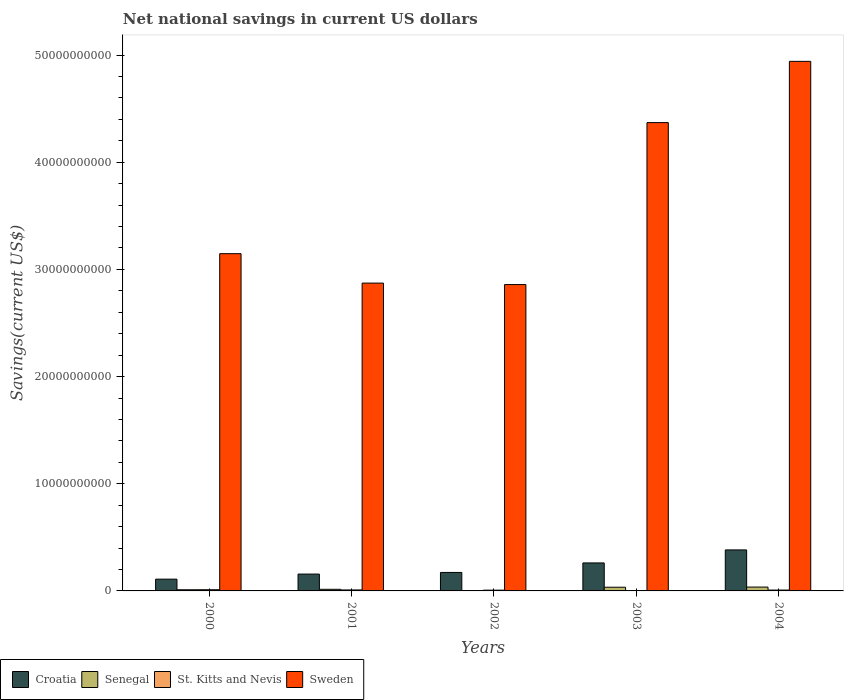How many different coloured bars are there?
Give a very brief answer. 4. How many bars are there on the 1st tick from the left?
Your answer should be very brief. 4. How many bars are there on the 1st tick from the right?
Offer a very short reply. 4. What is the label of the 1st group of bars from the left?
Offer a terse response. 2000. What is the net national savings in Senegal in 2004?
Your answer should be compact. 3.59e+08. Across all years, what is the maximum net national savings in Croatia?
Keep it short and to the point. 3.83e+09. Across all years, what is the minimum net national savings in Sweden?
Give a very brief answer. 2.86e+1. In which year was the net national savings in St. Kitts and Nevis maximum?
Your answer should be compact. 2000. What is the total net national savings in Sweden in the graph?
Ensure brevity in your answer.  1.82e+11. What is the difference between the net national savings in St. Kitts and Nevis in 2003 and that in 2004?
Provide a short and direct response. -4.76e+07. What is the difference between the net national savings in St. Kitts and Nevis in 2000 and the net national savings in Sweden in 2002?
Your answer should be compact. -2.85e+1. What is the average net national savings in Senegal per year?
Your response must be concise. 1.96e+08. In the year 2004, what is the difference between the net national savings in Sweden and net national savings in Senegal?
Your response must be concise. 4.91e+1. In how many years, is the net national savings in Croatia greater than 36000000000 US$?
Your answer should be compact. 0. What is the ratio of the net national savings in St. Kitts and Nevis in 2000 to that in 2001?
Give a very brief answer. 1.23. What is the difference between the highest and the second highest net national savings in Croatia?
Keep it short and to the point. 1.21e+09. What is the difference between the highest and the lowest net national savings in Senegal?
Give a very brief answer. 3.42e+08. What does the 1st bar from the left in 2001 represents?
Offer a terse response. Croatia. What does the 3rd bar from the right in 2001 represents?
Give a very brief answer. Senegal. How many bars are there?
Your answer should be very brief. 20. How many years are there in the graph?
Your response must be concise. 5. What is the difference between two consecutive major ticks on the Y-axis?
Your answer should be very brief. 1.00e+1. Are the values on the major ticks of Y-axis written in scientific E-notation?
Provide a succinct answer. No. Where does the legend appear in the graph?
Make the answer very short. Bottom left. How are the legend labels stacked?
Provide a succinct answer. Horizontal. What is the title of the graph?
Keep it short and to the point. Net national savings in current US dollars. Does "Mali" appear as one of the legend labels in the graph?
Provide a succinct answer. No. What is the label or title of the Y-axis?
Provide a succinct answer. Savings(current US$). What is the Savings(current US$) in Croatia in 2000?
Your response must be concise. 1.10e+09. What is the Savings(current US$) in Senegal in 2000?
Your answer should be very brief. 1.09e+08. What is the Savings(current US$) in St. Kitts and Nevis in 2000?
Provide a short and direct response. 1.12e+08. What is the Savings(current US$) in Sweden in 2000?
Give a very brief answer. 3.15e+1. What is the Savings(current US$) of Croatia in 2001?
Keep it short and to the point. 1.57e+09. What is the Savings(current US$) of Senegal in 2001?
Your answer should be compact. 1.51e+08. What is the Savings(current US$) of St. Kitts and Nevis in 2001?
Provide a short and direct response. 9.14e+07. What is the Savings(current US$) in Sweden in 2001?
Your answer should be compact. 2.87e+1. What is the Savings(current US$) in Croatia in 2002?
Offer a terse response. 1.72e+09. What is the Savings(current US$) in Senegal in 2002?
Keep it short and to the point. 1.67e+07. What is the Savings(current US$) in St. Kitts and Nevis in 2002?
Give a very brief answer. 7.03e+07. What is the Savings(current US$) in Sweden in 2002?
Your answer should be compact. 2.86e+1. What is the Savings(current US$) of Croatia in 2003?
Your answer should be compact. 2.61e+09. What is the Savings(current US$) in Senegal in 2003?
Offer a very short reply. 3.44e+08. What is the Savings(current US$) of St. Kitts and Nevis in 2003?
Your response must be concise. 3.22e+07. What is the Savings(current US$) of Sweden in 2003?
Give a very brief answer. 4.37e+1. What is the Savings(current US$) in Croatia in 2004?
Make the answer very short. 3.83e+09. What is the Savings(current US$) in Senegal in 2004?
Your answer should be very brief. 3.59e+08. What is the Savings(current US$) of St. Kitts and Nevis in 2004?
Provide a short and direct response. 7.98e+07. What is the Savings(current US$) in Sweden in 2004?
Keep it short and to the point. 4.94e+1. Across all years, what is the maximum Savings(current US$) of Croatia?
Provide a succinct answer. 3.83e+09. Across all years, what is the maximum Savings(current US$) in Senegal?
Provide a succinct answer. 3.59e+08. Across all years, what is the maximum Savings(current US$) of St. Kitts and Nevis?
Your response must be concise. 1.12e+08. Across all years, what is the maximum Savings(current US$) in Sweden?
Ensure brevity in your answer.  4.94e+1. Across all years, what is the minimum Savings(current US$) of Croatia?
Keep it short and to the point. 1.10e+09. Across all years, what is the minimum Savings(current US$) of Senegal?
Offer a terse response. 1.67e+07. Across all years, what is the minimum Savings(current US$) of St. Kitts and Nevis?
Make the answer very short. 3.22e+07. Across all years, what is the minimum Savings(current US$) of Sweden?
Ensure brevity in your answer.  2.86e+1. What is the total Savings(current US$) in Croatia in the graph?
Your answer should be very brief. 1.08e+1. What is the total Savings(current US$) in Senegal in the graph?
Your answer should be very brief. 9.80e+08. What is the total Savings(current US$) of St. Kitts and Nevis in the graph?
Make the answer very short. 3.86e+08. What is the total Savings(current US$) of Sweden in the graph?
Ensure brevity in your answer.  1.82e+11. What is the difference between the Savings(current US$) of Croatia in 2000 and that in 2001?
Your answer should be very brief. -4.74e+08. What is the difference between the Savings(current US$) in Senegal in 2000 and that in 2001?
Offer a terse response. -4.20e+07. What is the difference between the Savings(current US$) of St. Kitts and Nevis in 2000 and that in 2001?
Keep it short and to the point. 2.07e+07. What is the difference between the Savings(current US$) of Sweden in 2000 and that in 2001?
Your answer should be compact. 2.75e+09. What is the difference between the Savings(current US$) of Croatia in 2000 and that in 2002?
Make the answer very short. -6.25e+08. What is the difference between the Savings(current US$) in Senegal in 2000 and that in 2002?
Offer a terse response. 9.25e+07. What is the difference between the Savings(current US$) of St. Kitts and Nevis in 2000 and that in 2002?
Offer a terse response. 4.18e+07. What is the difference between the Savings(current US$) of Sweden in 2000 and that in 2002?
Your response must be concise. 2.88e+09. What is the difference between the Savings(current US$) of Croatia in 2000 and that in 2003?
Offer a terse response. -1.51e+09. What is the difference between the Savings(current US$) in Senegal in 2000 and that in 2003?
Your answer should be very brief. -2.35e+08. What is the difference between the Savings(current US$) of St. Kitts and Nevis in 2000 and that in 2003?
Provide a succinct answer. 7.99e+07. What is the difference between the Savings(current US$) of Sweden in 2000 and that in 2003?
Offer a terse response. -1.22e+1. What is the difference between the Savings(current US$) of Croatia in 2000 and that in 2004?
Give a very brief answer. -2.73e+09. What is the difference between the Savings(current US$) in Senegal in 2000 and that in 2004?
Give a very brief answer. -2.50e+08. What is the difference between the Savings(current US$) in St. Kitts and Nevis in 2000 and that in 2004?
Give a very brief answer. 3.23e+07. What is the difference between the Savings(current US$) of Sweden in 2000 and that in 2004?
Your answer should be very brief. -1.79e+1. What is the difference between the Savings(current US$) of Croatia in 2001 and that in 2002?
Ensure brevity in your answer.  -1.51e+08. What is the difference between the Savings(current US$) of Senegal in 2001 and that in 2002?
Provide a succinct answer. 1.35e+08. What is the difference between the Savings(current US$) in St. Kitts and Nevis in 2001 and that in 2002?
Your answer should be compact. 2.11e+07. What is the difference between the Savings(current US$) in Sweden in 2001 and that in 2002?
Keep it short and to the point. 1.37e+08. What is the difference between the Savings(current US$) in Croatia in 2001 and that in 2003?
Your response must be concise. -1.04e+09. What is the difference between the Savings(current US$) of Senegal in 2001 and that in 2003?
Make the answer very short. -1.93e+08. What is the difference between the Savings(current US$) in St. Kitts and Nevis in 2001 and that in 2003?
Make the answer very short. 5.92e+07. What is the difference between the Savings(current US$) in Sweden in 2001 and that in 2003?
Your answer should be compact. -1.50e+1. What is the difference between the Savings(current US$) of Croatia in 2001 and that in 2004?
Ensure brevity in your answer.  -2.25e+09. What is the difference between the Savings(current US$) in Senegal in 2001 and that in 2004?
Ensure brevity in your answer.  -2.08e+08. What is the difference between the Savings(current US$) in St. Kitts and Nevis in 2001 and that in 2004?
Give a very brief answer. 1.16e+07. What is the difference between the Savings(current US$) in Sweden in 2001 and that in 2004?
Provide a succinct answer. -2.07e+1. What is the difference between the Savings(current US$) of Croatia in 2002 and that in 2003?
Ensure brevity in your answer.  -8.88e+08. What is the difference between the Savings(current US$) of Senegal in 2002 and that in 2003?
Make the answer very short. -3.28e+08. What is the difference between the Savings(current US$) in St. Kitts and Nevis in 2002 and that in 2003?
Provide a succinct answer. 3.81e+07. What is the difference between the Savings(current US$) in Sweden in 2002 and that in 2003?
Your response must be concise. -1.51e+1. What is the difference between the Savings(current US$) of Croatia in 2002 and that in 2004?
Provide a short and direct response. -2.10e+09. What is the difference between the Savings(current US$) in Senegal in 2002 and that in 2004?
Make the answer very short. -3.42e+08. What is the difference between the Savings(current US$) of St. Kitts and Nevis in 2002 and that in 2004?
Provide a short and direct response. -9.49e+06. What is the difference between the Savings(current US$) of Sweden in 2002 and that in 2004?
Provide a succinct answer. -2.08e+1. What is the difference between the Savings(current US$) of Croatia in 2003 and that in 2004?
Your response must be concise. -1.21e+09. What is the difference between the Savings(current US$) of Senegal in 2003 and that in 2004?
Ensure brevity in your answer.  -1.45e+07. What is the difference between the Savings(current US$) of St. Kitts and Nevis in 2003 and that in 2004?
Offer a very short reply. -4.76e+07. What is the difference between the Savings(current US$) in Sweden in 2003 and that in 2004?
Ensure brevity in your answer.  -5.72e+09. What is the difference between the Savings(current US$) of Croatia in 2000 and the Savings(current US$) of Senegal in 2001?
Provide a short and direct response. 9.48e+08. What is the difference between the Savings(current US$) of Croatia in 2000 and the Savings(current US$) of St. Kitts and Nevis in 2001?
Ensure brevity in your answer.  1.01e+09. What is the difference between the Savings(current US$) in Croatia in 2000 and the Savings(current US$) in Sweden in 2001?
Ensure brevity in your answer.  -2.76e+1. What is the difference between the Savings(current US$) of Senegal in 2000 and the Savings(current US$) of St. Kitts and Nevis in 2001?
Offer a very short reply. 1.78e+07. What is the difference between the Savings(current US$) in Senegal in 2000 and the Savings(current US$) in Sweden in 2001?
Keep it short and to the point. -2.86e+1. What is the difference between the Savings(current US$) of St. Kitts and Nevis in 2000 and the Savings(current US$) of Sweden in 2001?
Keep it short and to the point. -2.86e+1. What is the difference between the Savings(current US$) of Croatia in 2000 and the Savings(current US$) of Senegal in 2002?
Your answer should be compact. 1.08e+09. What is the difference between the Savings(current US$) in Croatia in 2000 and the Savings(current US$) in St. Kitts and Nevis in 2002?
Keep it short and to the point. 1.03e+09. What is the difference between the Savings(current US$) in Croatia in 2000 and the Savings(current US$) in Sweden in 2002?
Offer a terse response. -2.75e+1. What is the difference between the Savings(current US$) of Senegal in 2000 and the Savings(current US$) of St. Kitts and Nevis in 2002?
Make the answer very short. 3.89e+07. What is the difference between the Savings(current US$) in Senegal in 2000 and the Savings(current US$) in Sweden in 2002?
Your answer should be compact. -2.85e+1. What is the difference between the Savings(current US$) of St. Kitts and Nevis in 2000 and the Savings(current US$) of Sweden in 2002?
Provide a succinct answer. -2.85e+1. What is the difference between the Savings(current US$) in Croatia in 2000 and the Savings(current US$) in Senegal in 2003?
Your response must be concise. 7.55e+08. What is the difference between the Savings(current US$) in Croatia in 2000 and the Savings(current US$) in St. Kitts and Nevis in 2003?
Keep it short and to the point. 1.07e+09. What is the difference between the Savings(current US$) in Croatia in 2000 and the Savings(current US$) in Sweden in 2003?
Provide a succinct answer. -4.26e+1. What is the difference between the Savings(current US$) in Senegal in 2000 and the Savings(current US$) in St. Kitts and Nevis in 2003?
Offer a terse response. 7.70e+07. What is the difference between the Savings(current US$) in Senegal in 2000 and the Savings(current US$) in Sweden in 2003?
Offer a very short reply. -4.36e+1. What is the difference between the Savings(current US$) in St. Kitts and Nevis in 2000 and the Savings(current US$) in Sweden in 2003?
Offer a very short reply. -4.36e+1. What is the difference between the Savings(current US$) in Croatia in 2000 and the Savings(current US$) in Senegal in 2004?
Make the answer very short. 7.40e+08. What is the difference between the Savings(current US$) in Croatia in 2000 and the Savings(current US$) in St. Kitts and Nevis in 2004?
Offer a terse response. 1.02e+09. What is the difference between the Savings(current US$) of Croatia in 2000 and the Savings(current US$) of Sweden in 2004?
Offer a very short reply. -4.83e+1. What is the difference between the Savings(current US$) in Senegal in 2000 and the Savings(current US$) in St. Kitts and Nevis in 2004?
Your answer should be very brief. 2.94e+07. What is the difference between the Savings(current US$) of Senegal in 2000 and the Savings(current US$) of Sweden in 2004?
Provide a succinct answer. -4.93e+1. What is the difference between the Savings(current US$) of St. Kitts and Nevis in 2000 and the Savings(current US$) of Sweden in 2004?
Offer a terse response. -4.93e+1. What is the difference between the Savings(current US$) of Croatia in 2001 and the Savings(current US$) of Senegal in 2002?
Offer a very short reply. 1.56e+09. What is the difference between the Savings(current US$) in Croatia in 2001 and the Savings(current US$) in St. Kitts and Nevis in 2002?
Make the answer very short. 1.50e+09. What is the difference between the Savings(current US$) in Croatia in 2001 and the Savings(current US$) in Sweden in 2002?
Offer a terse response. -2.70e+1. What is the difference between the Savings(current US$) of Senegal in 2001 and the Savings(current US$) of St. Kitts and Nevis in 2002?
Give a very brief answer. 8.09e+07. What is the difference between the Savings(current US$) of Senegal in 2001 and the Savings(current US$) of Sweden in 2002?
Offer a very short reply. -2.84e+1. What is the difference between the Savings(current US$) in St. Kitts and Nevis in 2001 and the Savings(current US$) in Sweden in 2002?
Give a very brief answer. -2.85e+1. What is the difference between the Savings(current US$) of Croatia in 2001 and the Savings(current US$) of Senegal in 2003?
Offer a terse response. 1.23e+09. What is the difference between the Savings(current US$) in Croatia in 2001 and the Savings(current US$) in St. Kitts and Nevis in 2003?
Make the answer very short. 1.54e+09. What is the difference between the Savings(current US$) of Croatia in 2001 and the Savings(current US$) of Sweden in 2003?
Make the answer very short. -4.21e+1. What is the difference between the Savings(current US$) of Senegal in 2001 and the Savings(current US$) of St. Kitts and Nevis in 2003?
Your answer should be compact. 1.19e+08. What is the difference between the Savings(current US$) in Senegal in 2001 and the Savings(current US$) in Sweden in 2003?
Offer a terse response. -4.35e+1. What is the difference between the Savings(current US$) of St. Kitts and Nevis in 2001 and the Savings(current US$) of Sweden in 2003?
Offer a very short reply. -4.36e+1. What is the difference between the Savings(current US$) in Croatia in 2001 and the Savings(current US$) in Senegal in 2004?
Offer a terse response. 1.21e+09. What is the difference between the Savings(current US$) in Croatia in 2001 and the Savings(current US$) in St. Kitts and Nevis in 2004?
Make the answer very short. 1.49e+09. What is the difference between the Savings(current US$) in Croatia in 2001 and the Savings(current US$) in Sweden in 2004?
Your answer should be very brief. -4.78e+1. What is the difference between the Savings(current US$) of Senegal in 2001 and the Savings(current US$) of St. Kitts and Nevis in 2004?
Provide a succinct answer. 7.14e+07. What is the difference between the Savings(current US$) of Senegal in 2001 and the Savings(current US$) of Sweden in 2004?
Offer a terse response. -4.93e+1. What is the difference between the Savings(current US$) of St. Kitts and Nevis in 2001 and the Savings(current US$) of Sweden in 2004?
Your answer should be compact. -4.93e+1. What is the difference between the Savings(current US$) in Croatia in 2002 and the Savings(current US$) in Senegal in 2003?
Give a very brief answer. 1.38e+09. What is the difference between the Savings(current US$) in Croatia in 2002 and the Savings(current US$) in St. Kitts and Nevis in 2003?
Ensure brevity in your answer.  1.69e+09. What is the difference between the Savings(current US$) of Croatia in 2002 and the Savings(current US$) of Sweden in 2003?
Make the answer very short. -4.20e+1. What is the difference between the Savings(current US$) in Senegal in 2002 and the Savings(current US$) in St. Kitts and Nevis in 2003?
Offer a very short reply. -1.55e+07. What is the difference between the Savings(current US$) in Senegal in 2002 and the Savings(current US$) in Sweden in 2003?
Offer a very short reply. -4.37e+1. What is the difference between the Savings(current US$) in St. Kitts and Nevis in 2002 and the Savings(current US$) in Sweden in 2003?
Your answer should be compact. -4.36e+1. What is the difference between the Savings(current US$) in Croatia in 2002 and the Savings(current US$) in Senegal in 2004?
Provide a short and direct response. 1.36e+09. What is the difference between the Savings(current US$) in Croatia in 2002 and the Savings(current US$) in St. Kitts and Nevis in 2004?
Give a very brief answer. 1.64e+09. What is the difference between the Savings(current US$) in Croatia in 2002 and the Savings(current US$) in Sweden in 2004?
Offer a terse response. -4.77e+1. What is the difference between the Savings(current US$) of Senegal in 2002 and the Savings(current US$) of St. Kitts and Nevis in 2004?
Offer a very short reply. -6.31e+07. What is the difference between the Savings(current US$) in Senegal in 2002 and the Savings(current US$) in Sweden in 2004?
Your answer should be very brief. -4.94e+1. What is the difference between the Savings(current US$) in St. Kitts and Nevis in 2002 and the Savings(current US$) in Sweden in 2004?
Ensure brevity in your answer.  -4.93e+1. What is the difference between the Savings(current US$) of Croatia in 2003 and the Savings(current US$) of Senegal in 2004?
Provide a short and direct response. 2.25e+09. What is the difference between the Savings(current US$) of Croatia in 2003 and the Savings(current US$) of St. Kitts and Nevis in 2004?
Keep it short and to the point. 2.53e+09. What is the difference between the Savings(current US$) of Croatia in 2003 and the Savings(current US$) of Sweden in 2004?
Offer a terse response. -4.68e+1. What is the difference between the Savings(current US$) of Senegal in 2003 and the Savings(current US$) of St. Kitts and Nevis in 2004?
Keep it short and to the point. 2.65e+08. What is the difference between the Savings(current US$) in Senegal in 2003 and the Savings(current US$) in Sweden in 2004?
Keep it short and to the point. -4.91e+1. What is the difference between the Savings(current US$) of St. Kitts and Nevis in 2003 and the Savings(current US$) of Sweden in 2004?
Your answer should be compact. -4.94e+1. What is the average Savings(current US$) of Croatia per year?
Ensure brevity in your answer.  2.17e+09. What is the average Savings(current US$) of Senegal per year?
Provide a succinct answer. 1.96e+08. What is the average Savings(current US$) in St. Kitts and Nevis per year?
Your answer should be very brief. 7.72e+07. What is the average Savings(current US$) of Sweden per year?
Provide a short and direct response. 3.64e+1. In the year 2000, what is the difference between the Savings(current US$) of Croatia and Savings(current US$) of Senegal?
Your answer should be compact. 9.90e+08. In the year 2000, what is the difference between the Savings(current US$) in Croatia and Savings(current US$) in St. Kitts and Nevis?
Your answer should be compact. 9.87e+08. In the year 2000, what is the difference between the Savings(current US$) in Croatia and Savings(current US$) in Sweden?
Your answer should be compact. -3.04e+1. In the year 2000, what is the difference between the Savings(current US$) in Senegal and Savings(current US$) in St. Kitts and Nevis?
Provide a short and direct response. -2.90e+06. In the year 2000, what is the difference between the Savings(current US$) of Senegal and Savings(current US$) of Sweden?
Provide a short and direct response. -3.14e+1. In the year 2000, what is the difference between the Savings(current US$) in St. Kitts and Nevis and Savings(current US$) in Sweden?
Keep it short and to the point. -3.14e+1. In the year 2001, what is the difference between the Savings(current US$) of Croatia and Savings(current US$) of Senegal?
Provide a short and direct response. 1.42e+09. In the year 2001, what is the difference between the Savings(current US$) of Croatia and Savings(current US$) of St. Kitts and Nevis?
Offer a terse response. 1.48e+09. In the year 2001, what is the difference between the Savings(current US$) in Croatia and Savings(current US$) in Sweden?
Offer a terse response. -2.71e+1. In the year 2001, what is the difference between the Savings(current US$) in Senegal and Savings(current US$) in St. Kitts and Nevis?
Offer a very short reply. 5.98e+07. In the year 2001, what is the difference between the Savings(current US$) in Senegal and Savings(current US$) in Sweden?
Ensure brevity in your answer.  -2.86e+1. In the year 2001, what is the difference between the Savings(current US$) of St. Kitts and Nevis and Savings(current US$) of Sweden?
Your answer should be compact. -2.86e+1. In the year 2002, what is the difference between the Savings(current US$) of Croatia and Savings(current US$) of Senegal?
Ensure brevity in your answer.  1.71e+09. In the year 2002, what is the difference between the Savings(current US$) in Croatia and Savings(current US$) in St. Kitts and Nevis?
Your answer should be compact. 1.65e+09. In the year 2002, what is the difference between the Savings(current US$) in Croatia and Savings(current US$) in Sweden?
Give a very brief answer. -2.69e+1. In the year 2002, what is the difference between the Savings(current US$) of Senegal and Savings(current US$) of St. Kitts and Nevis?
Offer a very short reply. -5.36e+07. In the year 2002, what is the difference between the Savings(current US$) in Senegal and Savings(current US$) in Sweden?
Give a very brief answer. -2.86e+1. In the year 2002, what is the difference between the Savings(current US$) of St. Kitts and Nevis and Savings(current US$) of Sweden?
Ensure brevity in your answer.  -2.85e+1. In the year 2003, what is the difference between the Savings(current US$) in Croatia and Savings(current US$) in Senegal?
Give a very brief answer. 2.27e+09. In the year 2003, what is the difference between the Savings(current US$) in Croatia and Savings(current US$) in St. Kitts and Nevis?
Provide a short and direct response. 2.58e+09. In the year 2003, what is the difference between the Savings(current US$) in Croatia and Savings(current US$) in Sweden?
Keep it short and to the point. -4.11e+1. In the year 2003, what is the difference between the Savings(current US$) in Senegal and Savings(current US$) in St. Kitts and Nevis?
Your response must be concise. 3.12e+08. In the year 2003, what is the difference between the Savings(current US$) in Senegal and Savings(current US$) in Sweden?
Give a very brief answer. -4.34e+1. In the year 2003, what is the difference between the Savings(current US$) of St. Kitts and Nevis and Savings(current US$) of Sweden?
Keep it short and to the point. -4.37e+1. In the year 2004, what is the difference between the Savings(current US$) of Croatia and Savings(current US$) of Senegal?
Offer a very short reply. 3.47e+09. In the year 2004, what is the difference between the Savings(current US$) of Croatia and Savings(current US$) of St. Kitts and Nevis?
Your answer should be very brief. 3.75e+09. In the year 2004, what is the difference between the Savings(current US$) of Croatia and Savings(current US$) of Sweden?
Provide a succinct answer. -4.56e+1. In the year 2004, what is the difference between the Savings(current US$) in Senegal and Savings(current US$) in St. Kitts and Nevis?
Ensure brevity in your answer.  2.79e+08. In the year 2004, what is the difference between the Savings(current US$) of Senegal and Savings(current US$) of Sweden?
Your response must be concise. -4.91e+1. In the year 2004, what is the difference between the Savings(current US$) in St. Kitts and Nevis and Savings(current US$) in Sweden?
Your response must be concise. -4.93e+1. What is the ratio of the Savings(current US$) of Croatia in 2000 to that in 2001?
Your answer should be compact. 0.7. What is the ratio of the Savings(current US$) in Senegal in 2000 to that in 2001?
Your response must be concise. 0.72. What is the ratio of the Savings(current US$) in St. Kitts and Nevis in 2000 to that in 2001?
Provide a short and direct response. 1.23. What is the ratio of the Savings(current US$) in Sweden in 2000 to that in 2001?
Your response must be concise. 1.1. What is the ratio of the Savings(current US$) in Croatia in 2000 to that in 2002?
Make the answer very short. 0.64. What is the ratio of the Savings(current US$) in Senegal in 2000 to that in 2002?
Your answer should be compact. 6.55. What is the ratio of the Savings(current US$) in St. Kitts and Nevis in 2000 to that in 2002?
Ensure brevity in your answer.  1.59. What is the ratio of the Savings(current US$) in Sweden in 2000 to that in 2002?
Keep it short and to the point. 1.1. What is the ratio of the Savings(current US$) in Croatia in 2000 to that in 2003?
Ensure brevity in your answer.  0.42. What is the ratio of the Savings(current US$) of Senegal in 2000 to that in 2003?
Your answer should be very brief. 0.32. What is the ratio of the Savings(current US$) of St. Kitts and Nevis in 2000 to that in 2003?
Your answer should be compact. 3.48. What is the ratio of the Savings(current US$) of Sweden in 2000 to that in 2003?
Provide a succinct answer. 0.72. What is the ratio of the Savings(current US$) in Croatia in 2000 to that in 2004?
Give a very brief answer. 0.29. What is the ratio of the Savings(current US$) of Senegal in 2000 to that in 2004?
Keep it short and to the point. 0.3. What is the ratio of the Savings(current US$) in St. Kitts and Nevis in 2000 to that in 2004?
Keep it short and to the point. 1.4. What is the ratio of the Savings(current US$) in Sweden in 2000 to that in 2004?
Your answer should be compact. 0.64. What is the ratio of the Savings(current US$) of Croatia in 2001 to that in 2002?
Offer a terse response. 0.91. What is the ratio of the Savings(current US$) of Senegal in 2001 to that in 2002?
Provide a short and direct response. 9.07. What is the ratio of the Savings(current US$) in St. Kitts and Nevis in 2001 to that in 2002?
Offer a terse response. 1.3. What is the ratio of the Savings(current US$) in Sweden in 2001 to that in 2002?
Your answer should be compact. 1. What is the ratio of the Savings(current US$) in Croatia in 2001 to that in 2003?
Provide a short and direct response. 0.6. What is the ratio of the Savings(current US$) in Senegal in 2001 to that in 2003?
Provide a short and direct response. 0.44. What is the ratio of the Savings(current US$) of St. Kitts and Nevis in 2001 to that in 2003?
Provide a succinct answer. 2.84. What is the ratio of the Savings(current US$) in Sweden in 2001 to that in 2003?
Your answer should be very brief. 0.66. What is the ratio of the Savings(current US$) of Croatia in 2001 to that in 2004?
Offer a very short reply. 0.41. What is the ratio of the Savings(current US$) in Senegal in 2001 to that in 2004?
Give a very brief answer. 0.42. What is the ratio of the Savings(current US$) of St. Kitts and Nevis in 2001 to that in 2004?
Your response must be concise. 1.15. What is the ratio of the Savings(current US$) in Sweden in 2001 to that in 2004?
Keep it short and to the point. 0.58. What is the ratio of the Savings(current US$) in Croatia in 2002 to that in 2003?
Make the answer very short. 0.66. What is the ratio of the Savings(current US$) of Senegal in 2002 to that in 2003?
Your answer should be very brief. 0.05. What is the ratio of the Savings(current US$) of St. Kitts and Nevis in 2002 to that in 2003?
Make the answer very short. 2.18. What is the ratio of the Savings(current US$) of Sweden in 2002 to that in 2003?
Give a very brief answer. 0.65. What is the ratio of the Savings(current US$) of Croatia in 2002 to that in 2004?
Offer a terse response. 0.45. What is the ratio of the Savings(current US$) in Senegal in 2002 to that in 2004?
Keep it short and to the point. 0.05. What is the ratio of the Savings(current US$) of St. Kitts and Nevis in 2002 to that in 2004?
Provide a short and direct response. 0.88. What is the ratio of the Savings(current US$) of Sweden in 2002 to that in 2004?
Your response must be concise. 0.58. What is the ratio of the Savings(current US$) of Croatia in 2003 to that in 2004?
Ensure brevity in your answer.  0.68. What is the ratio of the Savings(current US$) of Senegal in 2003 to that in 2004?
Provide a short and direct response. 0.96. What is the ratio of the Savings(current US$) of St. Kitts and Nevis in 2003 to that in 2004?
Offer a terse response. 0.4. What is the ratio of the Savings(current US$) in Sweden in 2003 to that in 2004?
Make the answer very short. 0.88. What is the difference between the highest and the second highest Savings(current US$) of Croatia?
Make the answer very short. 1.21e+09. What is the difference between the highest and the second highest Savings(current US$) of Senegal?
Your response must be concise. 1.45e+07. What is the difference between the highest and the second highest Savings(current US$) of St. Kitts and Nevis?
Keep it short and to the point. 2.07e+07. What is the difference between the highest and the second highest Savings(current US$) in Sweden?
Provide a short and direct response. 5.72e+09. What is the difference between the highest and the lowest Savings(current US$) in Croatia?
Offer a terse response. 2.73e+09. What is the difference between the highest and the lowest Savings(current US$) in Senegal?
Provide a short and direct response. 3.42e+08. What is the difference between the highest and the lowest Savings(current US$) of St. Kitts and Nevis?
Offer a terse response. 7.99e+07. What is the difference between the highest and the lowest Savings(current US$) of Sweden?
Offer a very short reply. 2.08e+1. 